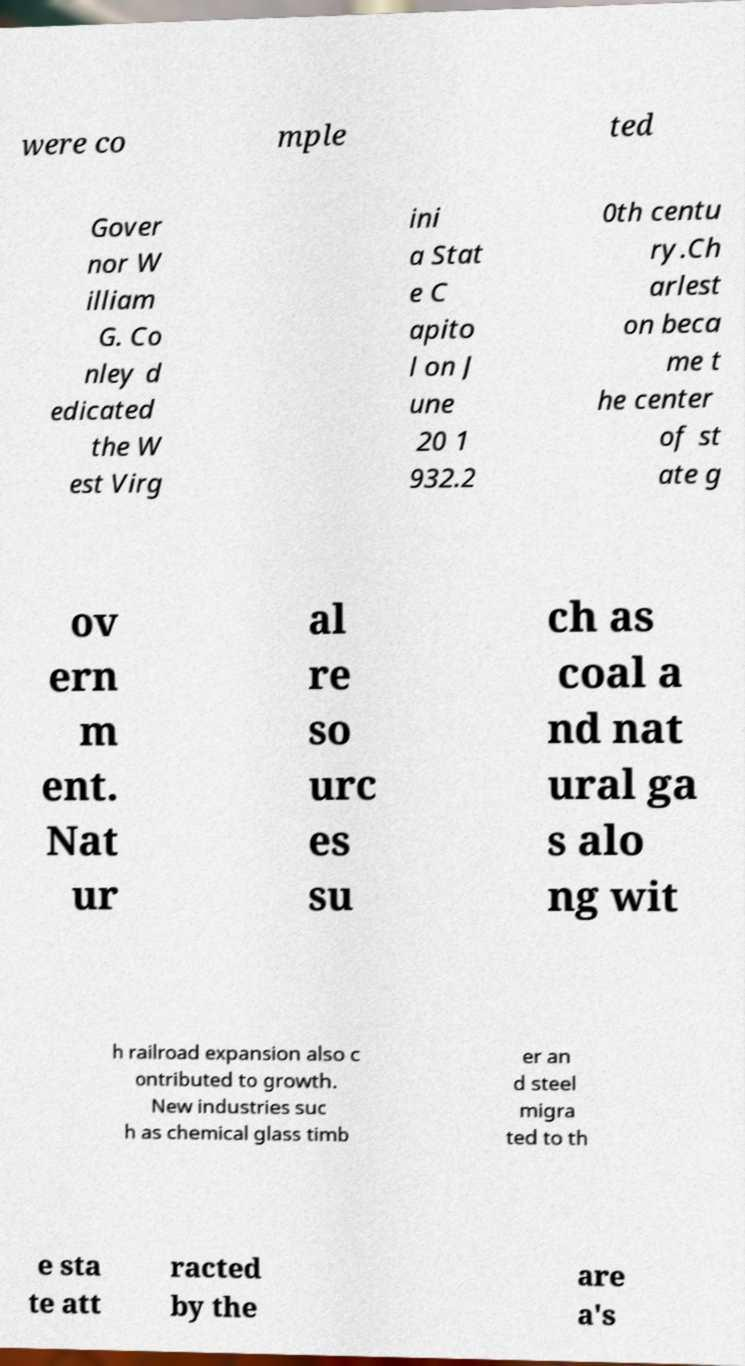I need the written content from this picture converted into text. Can you do that? were co mple ted Gover nor W illiam G. Co nley d edicated the W est Virg ini a Stat e C apito l on J une 20 1 932.2 0th centu ry.Ch arlest on beca me t he center of st ate g ov ern m ent. Nat ur al re so urc es su ch as coal a nd nat ural ga s alo ng wit h railroad expansion also c ontributed to growth. New industries suc h as chemical glass timb er an d steel migra ted to th e sta te att racted by the are a's 